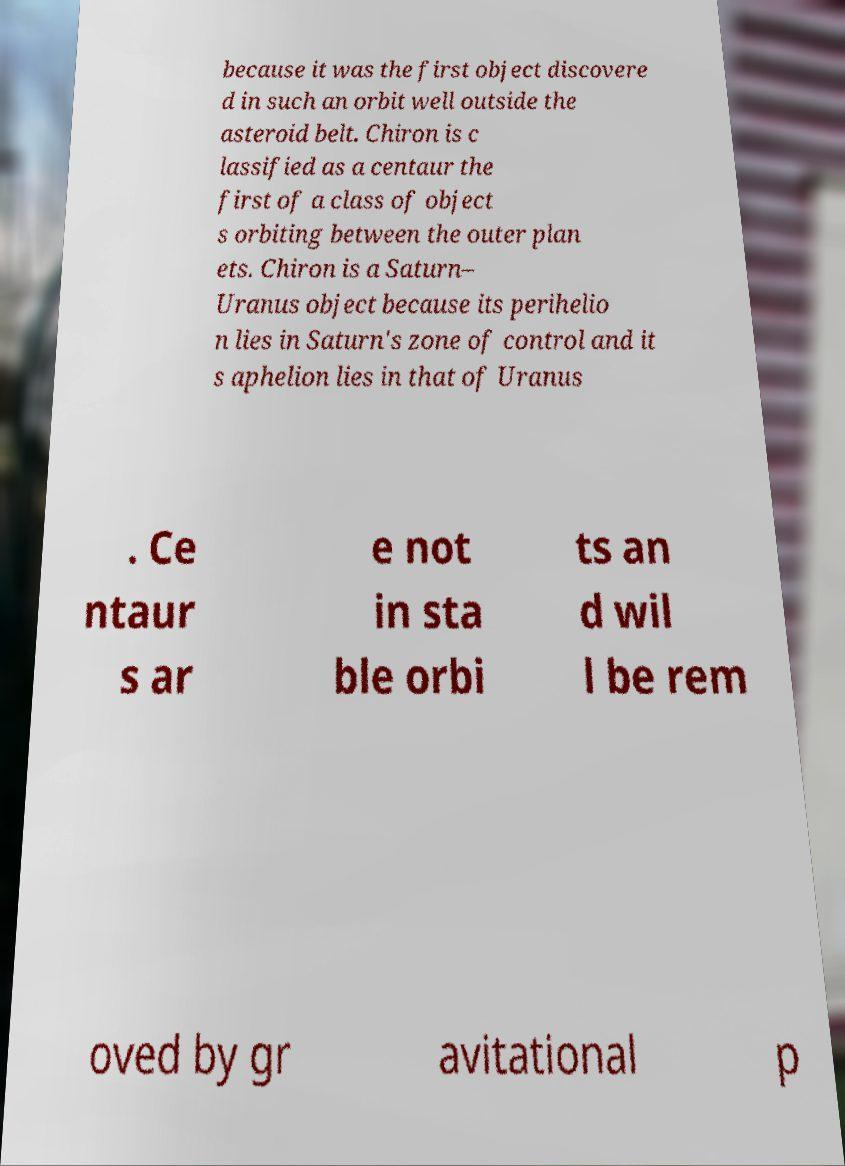Please read and relay the text visible in this image. What does it say? because it was the first object discovere d in such an orbit well outside the asteroid belt. Chiron is c lassified as a centaur the first of a class of object s orbiting between the outer plan ets. Chiron is a Saturn– Uranus object because its perihelio n lies in Saturn's zone of control and it s aphelion lies in that of Uranus . Ce ntaur s ar e not in sta ble orbi ts an d wil l be rem oved by gr avitational p 